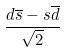Convert formula to latex. <formula><loc_0><loc_0><loc_500><loc_500>\frac { d \overline { s } - s \overline { d } } { \sqrt { 2 } }</formula> 